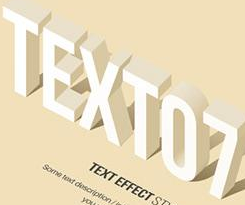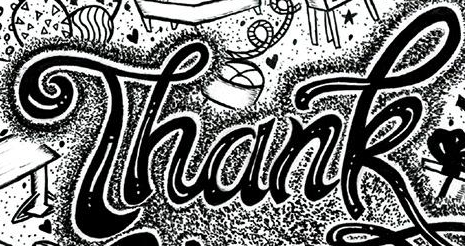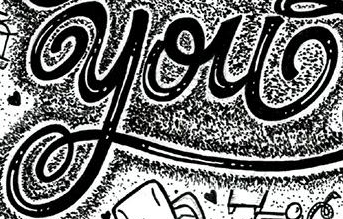Identify the words shown in these images in order, separated by a semicolon. TEXTO7; Thank; you 